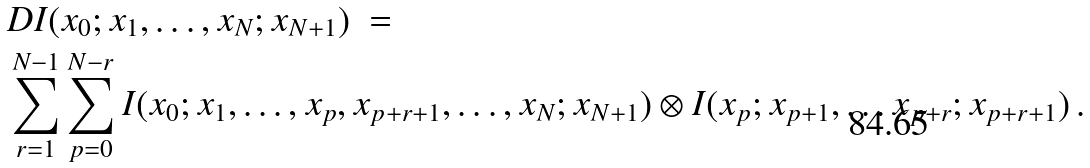Convert formula to latex. <formula><loc_0><loc_0><loc_500><loc_500>& D I ( x _ { 0 } ; x _ { 1 } , \dots , x _ { N } ; x _ { N + 1 } ) \ = \\ & \sum _ { r = 1 } ^ { N - 1 } \sum _ { p = 0 } ^ { N - r } I ( x _ { 0 } ; x _ { 1 } , \dots , x _ { p } , x _ { p + r + 1 } , \dots , x _ { N } ; x _ { N + 1 } ) \otimes I ( x _ { p } ; x _ { p + 1 } , \dots x _ { p + r } ; x _ { p + r + 1 } ) \, .</formula> 